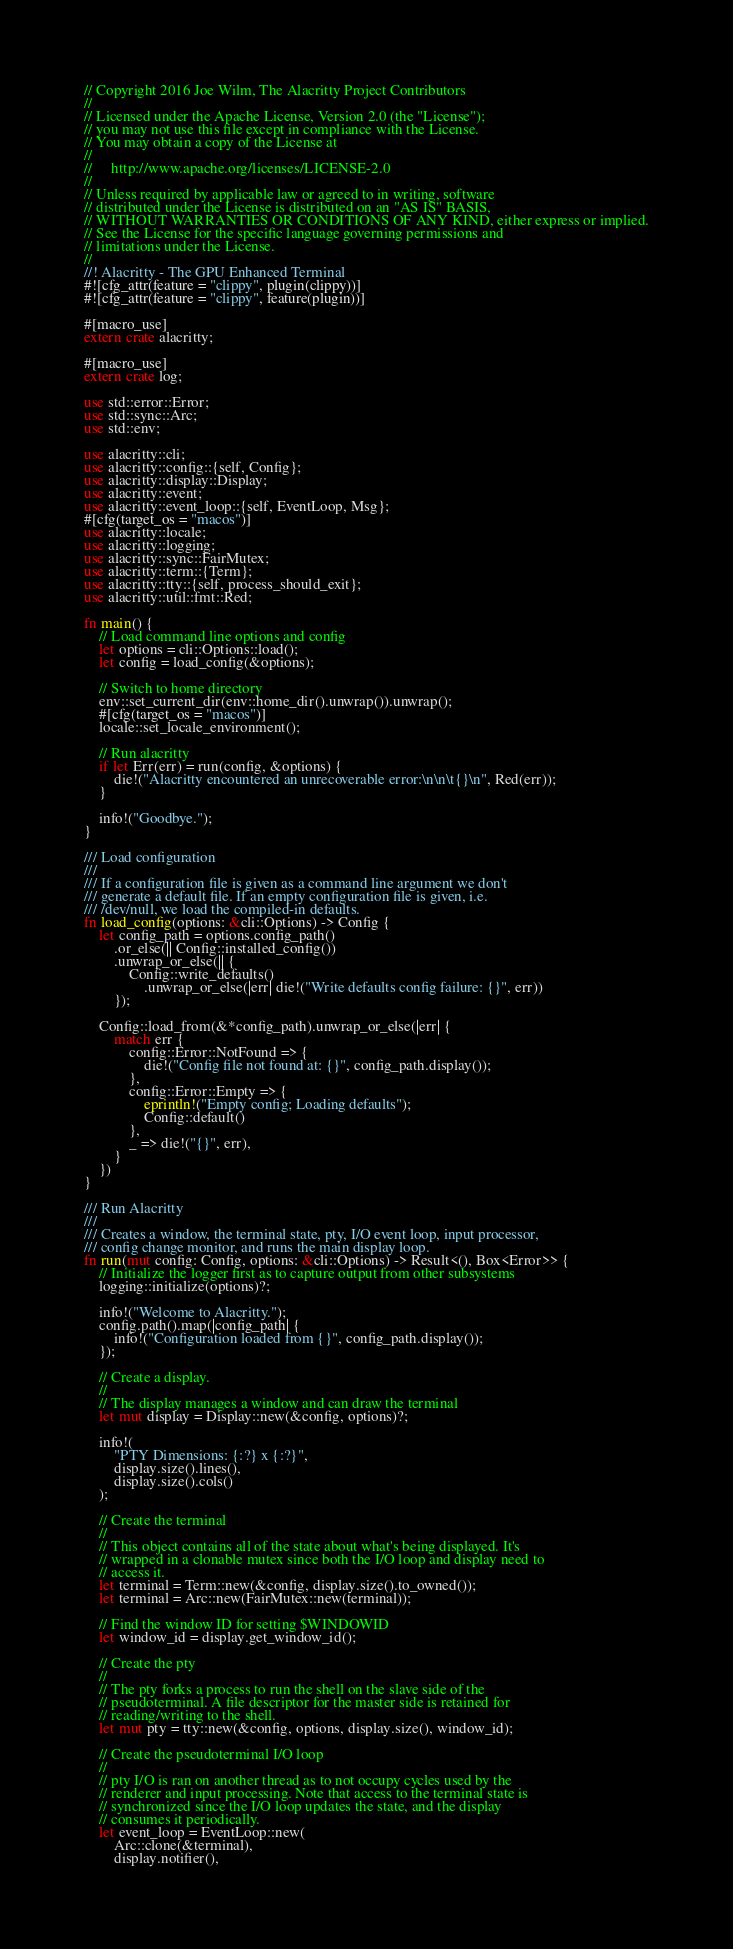<code> <loc_0><loc_0><loc_500><loc_500><_Rust_>// Copyright 2016 Joe Wilm, The Alacritty Project Contributors
//
// Licensed under the Apache License, Version 2.0 (the "License");
// you may not use this file except in compliance with the License.
// You may obtain a copy of the License at
//
//     http://www.apache.org/licenses/LICENSE-2.0
//
// Unless required by applicable law or agreed to in writing, software
// distributed under the License is distributed on an "AS IS" BASIS,
// WITHOUT WARRANTIES OR CONDITIONS OF ANY KIND, either express or implied.
// See the License for the specific language governing permissions and
// limitations under the License.
//
//! Alacritty - The GPU Enhanced Terminal
#![cfg_attr(feature = "clippy", plugin(clippy))]
#![cfg_attr(feature = "clippy", feature(plugin))]

#[macro_use]
extern crate alacritty;

#[macro_use]
extern crate log;

use std::error::Error;
use std::sync::Arc;
use std::env;

use alacritty::cli;
use alacritty::config::{self, Config};
use alacritty::display::Display;
use alacritty::event;
use alacritty::event_loop::{self, EventLoop, Msg};
#[cfg(target_os = "macos")]
use alacritty::locale;
use alacritty::logging;
use alacritty::sync::FairMutex;
use alacritty::term::{Term};
use alacritty::tty::{self, process_should_exit};
use alacritty::util::fmt::Red;

fn main() {
    // Load command line options and config
    let options = cli::Options::load();
    let config = load_config(&options);

    // Switch to home directory
    env::set_current_dir(env::home_dir().unwrap()).unwrap();
    #[cfg(target_os = "macos")]
    locale::set_locale_environment();

    // Run alacritty
    if let Err(err) = run(config, &options) {
        die!("Alacritty encountered an unrecoverable error:\n\n\t{}\n", Red(err));
    }

    info!("Goodbye.");
}

/// Load configuration
///
/// If a configuration file is given as a command line argument we don't
/// generate a default file. If an empty configuration file is given, i.e.
/// /dev/null, we load the compiled-in defaults.
fn load_config(options: &cli::Options) -> Config {
    let config_path = options.config_path()
        .or_else(|| Config::installed_config())
        .unwrap_or_else(|| {
            Config::write_defaults()
                .unwrap_or_else(|err| die!("Write defaults config failure: {}", err))
        });

    Config::load_from(&*config_path).unwrap_or_else(|err| {
        match err {
            config::Error::NotFound => {
                die!("Config file not found at: {}", config_path.display());
            },
            config::Error::Empty => {
                eprintln!("Empty config; Loading defaults");
                Config::default()
            },
            _ => die!("{}", err),
        }
    })
}

/// Run Alacritty
///
/// Creates a window, the terminal state, pty, I/O event loop, input processor,
/// config change monitor, and runs the main display loop.
fn run(mut config: Config, options: &cli::Options) -> Result<(), Box<Error>> {
    // Initialize the logger first as to capture output from other subsystems
    logging::initialize(options)?;

    info!("Welcome to Alacritty.");
    config.path().map(|config_path| {
        info!("Configuration loaded from {}", config_path.display());
    });

    // Create a display.
    //
    // The display manages a window and can draw the terminal
    let mut display = Display::new(&config, options)?;

    info!(
        "PTY Dimensions: {:?} x {:?}",
        display.size().lines(),
        display.size().cols()
    );

    // Create the terminal
    //
    // This object contains all of the state about what's being displayed. It's
    // wrapped in a clonable mutex since both the I/O loop and display need to
    // access it.
    let terminal = Term::new(&config, display.size().to_owned());
    let terminal = Arc::new(FairMutex::new(terminal));

    // Find the window ID for setting $WINDOWID
    let window_id = display.get_window_id();

    // Create the pty
    //
    // The pty forks a process to run the shell on the slave side of the
    // pseudoterminal. A file descriptor for the master side is retained for
    // reading/writing to the shell.
    let mut pty = tty::new(&config, options, display.size(), window_id);

    // Create the pseudoterminal I/O loop
    //
    // pty I/O is ran on another thread as to not occupy cycles used by the
    // renderer and input processing. Note that access to the terminal state is
    // synchronized since the I/O loop updates the state, and the display
    // consumes it periodically.
    let event_loop = EventLoop::new(
        Arc::clone(&terminal),
        display.notifier(),</code> 